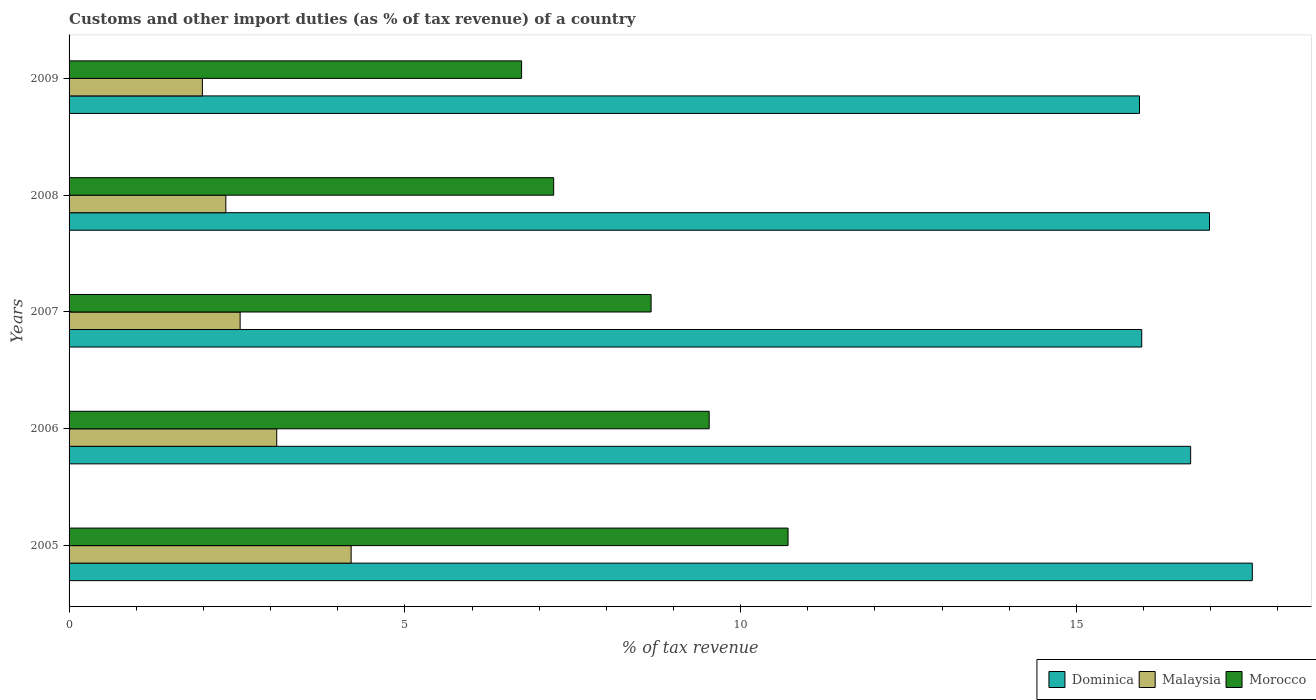How many groups of bars are there?
Offer a very short reply. 5. What is the label of the 3rd group of bars from the top?
Provide a succinct answer. 2007. In how many cases, is the number of bars for a given year not equal to the number of legend labels?
Provide a short and direct response. 0. What is the percentage of tax revenue from customs in Morocco in 2005?
Provide a short and direct response. 10.71. Across all years, what is the maximum percentage of tax revenue from customs in Malaysia?
Provide a short and direct response. 4.2. Across all years, what is the minimum percentage of tax revenue from customs in Morocco?
Ensure brevity in your answer.  6.74. What is the total percentage of tax revenue from customs in Dominica in the graph?
Make the answer very short. 83.21. What is the difference between the percentage of tax revenue from customs in Morocco in 2006 and that in 2009?
Offer a terse response. 2.79. What is the difference between the percentage of tax revenue from customs in Malaysia in 2006 and the percentage of tax revenue from customs in Dominica in 2009?
Offer a terse response. -12.85. What is the average percentage of tax revenue from customs in Dominica per year?
Offer a terse response. 16.64. In the year 2006, what is the difference between the percentage of tax revenue from customs in Dominica and percentage of tax revenue from customs in Malaysia?
Provide a succinct answer. 13.61. What is the ratio of the percentage of tax revenue from customs in Morocco in 2007 to that in 2008?
Provide a short and direct response. 1.2. What is the difference between the highest and the second highest percentage of tax revenue from customs in Morocco?
Your answer should be compact. 1.17. What is the difference between the highest and the lowest percentage of tax revenue from customs in Dominica?
Offer a very short reply. 1.68. In how many years, is the percentage of tax revenue from customs in Dominica greater than the average percentage of tax revenue from customs in Dominica taken over all years?
Give a very brief answer. 3. What does the 1st bar from the top in 2006 represents?
Provide a succinct answer. Morocco. What does the 2nd bar from the bottom in 2005 represents?
Your answer should be very brief. Malaysia. Is it the case that in every year, the sum of the percentage of tax revenue from customs in Dominica and percentage of tax revenue from customs in Malaysia is greater than the percentage of tax revenue from customs in Morocco?
Give a very brief answer. Yes. How many bars are there?
Make the answer very short. 15. Are all the bars in the graph horizontal?
Make the answer very short. Yes. How many years are there in the graph?
Make the answer very short. 5. What is the difference between two consecutive major ticks on the X-axis?
Your answer should be very brief. 5. Does the graph contain grids?
Offer a terse response. No. How many legend labels are there?
Provide a succinct answer. 3. How are the legend labels stacked?
Ensure brevity in your answer.  Horizontal. What is the title of the graph?
Your response must be concise. Customs and other import duties (as % of tax revenue) of a country. What is the label or title of the X-axis?
Offer a very short reply. % of tax revenue. What is the label or title of the Y-axis?
Your answer should be very brief. Years. What is the % of tax revenue in Dominica in 2005?
Your response must be concise. 17.62. What is the % of tax revenue in Malaysia in 2005?
Your answer should be very brief. 4.2. What is the % of tax revenue in Morocco in 2005?
Keep it short and to the point. 10.71. What is the % of tax revenue of Dominica in 2006?
Offer a terse response. 16.7. What is the % of tax revenue in Malaysia in 2006?
Keep it short and to the point. 3.09. What is the % of tax revenue in Morocco in 2006?
Provide a succinct answer. 9.53. What is the % of tax revenue of Dominica in 2007?
Give a very brief answer. 15.97. What is the % of tax revenue of Malaysia in 2007?
Give a very brief answer. 2.55. What is the % of tax revenue in Morocco in 2007?
Your response must be concise. 8.67. What is the % of tax revenue in Dominica in 2008?
Your answer should be very brief. 16.98. What is the % of tax revenue in Malaysia in 2008?
Make the answer very short. 2.33. What is the % of tax revenue in Morocco in 2008?
Offer a very short reply. 7.22. What is the % of tax revenue of Dominica in 2009?
Keep it short and to the point. 15.94. What is the % of tax revenue in Malaysia in 2009?
Keep it short and to the point. 1.99. What is the % of tax revenue in Morocco in 2009?
Provide a short and direct response. 6.74. Across all years, what is the maximum % of tax revenue in Dominica?
Offer a very short reply. 17.62. Across all years, what is the maximum % of tax revenue in Malaysia?
Make the answer very short. 4.2. Across all years, what is the maximum % of tax revenue of Morocco?
Keep it short and to the point. 10.71. Across all years, what is the minimum % of tax revenue of Dominica?
Give a very brief answer. 15.94. Across all years, what is the minimum % of tax revenue of Malaysia?
Give a very brief answer. 1.99. Across all years, what is the minimum % of tax revenue in Morocco?
Give a very brief answer. 6.74. What is the total % of tax revenue of Dominica in the graph?
Ensure brevity in your answer.  83.21. What is the total % of tax revenue in Malaysia in the graph?
Give a very brief answer. 14.16. What is the total % of tax revenue in Morocco in the graph?
Keep it short and to the point. 42.86. What is the difference between the % of tax revenue of Dominica in 2005 and that in 2006?
Your answer should be compact. 0.92. What is the difference between the % of tax revenue in Malaysia in 2005 and that in 2006?
Offer a terse response. 1.11. What is the difference between the % of tax revenue in Morocco in 2005 and that in 2006?
Make the answer very short. 1.17. What is the difference between the % of tax revenue of Dominica in 2005 and that in 2007?
Provide a short and direct response. 1.65. What is the difference between the % of tax revenue of Malaysia in 2005 and that in 2007?
Your answer should be very brief. 1.65. What is the difference between the % of tax revenue in Morocco in 2005 and that in 2007?
Give a very brief answer. 2.04. What is the difference between the % of tax revenue in Dominica in 2005 and that in 2008?
Provide a succinct answer. 0.64. What is the difference between the % of tax revenue in Malaysia in 2005 and that in 2008?
Your answer should be very brief. 1.87. What is the difference between the % of tax revenue of Morocco in 2005 and that in 2008?
Your response must be concise. 3.49. What is the difference between the % of tax revenue of Dominica in 2005 and that in 2009?
Provide a succinct answer. 1.68. What is the difference between the % of tax revenue of Malaysia in 2005 and that in 2009?
Provide a short and direct response. 2.21. What is the difference between the % of tax revenue in Morocco in 2005 and that in 2009?
Keep it short and to the point. 3.97. What is the difference between the % of tax revenue of Dominica in 2006 and that in 2007?
Make the answer very short. 0.73. What is the difference between the % of tax revenue in Malaysia in 2006 and that in 2007?
Your answer should be compact. 0.54. What is the difference between the % of tax revenue of Morocco in 2006 and that in 2007?
Your answer should be very brief. 0.87. What is the difference between the % of tax revenue of Dominica in 2006 and that in 2008?
Provide a short and direct response. -0.28. What is the difference between the % of tax revenue of Malaysia in 2006 and that in 2008?
Your answer should be very brief. 0.76. What is the difference between the % of tax revenue in Morocco in 2006 and that in 2008?
Provide a short and direct response. 2.32. What is the difference between the % of tax revenue of Dominica in 2006 and that in 2009?
Give a very brief answer. 0.76. What is the difference between the % of tax revenue of Malaysia in 2006 and that in 2009?
Give a very brief answer. 1.11. What is the difference between the % of tax revenue in Morocco in 2006 and that in 2009?
Keep it short and to the point. 2.79. What is the difference between the % of tax revenue in Dominica in 2007 and that in 2008?
Your response must be concise. -1.01. What is the difference between the % of tax revenue in Malaysia in 2007 and that in 2008?
Offer a terse response. 0.21. What is the difference between the % of tax revenue in Morocco in 2007 and that in 2008?
Ensure brevity in your answer.  1.45. What is the difference between the % of tax revenue in Dominica in 2007 and that in 2009?
Ensure brevity in your answer.  0.03. What is the difference between the % of tax revenue of Malaysia in 2007 and that in 2009?
Your response must be concise. 0.56. What is the difference between the % of tax revenue of Morocco in 2007 and that in 2009?
Ensure brevity in your answer.  1.93. What is the difference between the % of tax revenue in Dominica in 2008 and that in 2009?
Offer a terse response. 1.04. What is the difference between the % of tax revenue in Malaysia in 2008 and that in 2009?
Offer a very short reply. 0.35. What is the difference between the % of tax revenue in Morocco in 2008 and that in 2009?
Keep it short and to the point. 0.48. What is the difference between the % of tax revenue of Dominica in 2005 and the % of tax revenue of Malaysia in 2006?
Make the answer very short. 14.53. What is the difference between the % of tax revenue in Dominica in 2005 and the % of tax revenue in Morocco in 2006?
Offer a terse response. 8.09. What is the difference between the % of tax revenue of Malaysia in 2005 and the % of tax revenue of Morocco in 2006?
Provide a short and direct response. -5.33. What is the difference between the % of tax revenue of Dominica in 2005 and the % of tax revenue of Malaysia in 2007?
Keep it short and to the point. 15.07. What is the difference between the % of tax revenue of Dominica in 2005 and the % of tax revenue of Morocco in 2007?
Keep it short and to the point. 8.95. What is the difference between the % of tax revenue in Malaysia in 2005 and the % of tax revenue in Morocco in 2007?
Offer a terse response. -4.47. What is the difference between the % of tax revenue in Dominica in 2005 and the % of tax revenue in Malaysia in 2008?
Offer a terse response. 15.28. What is the difference between the % of tax revenue in Dominica in 2005 and the % of tax revenue in Morocco in 2008?
Give a very brief answer. 10.4. What is the difference between the % of tax revenue in Malaysia in 2005 and the % of tax revenue in Morocco in 2008?
Keep it short and to the point. -3.02. What is the difference between the % of tax revenue in Dominica in 2005 and the % of tax revenue in Malaysia in 2009?
Your answer should be compact. 15.63. What is the difference between the % of tax revenue of Dominica in 2005 and the % of tax revenue of Morocco in 2009?
Offer a terse response. 10.88. What is the difference between the % of tax revenue of Malaysia in 2005 and the % of tax revenue of Morocco in 2009?
Provide a succinct answer. -2.54. What is the difference between the % of tax revenue of Dominica in 2006 and the % of tax revenue of Malaysia in 2007?
Keep it short and to the point. 14.15. What is the difference between the % of tax revenue in Dominica in 2006 and the % of tax revenue in Morocco in 2007?
Offer a very short reply. 8.03. What is the difference between the % of tax revenue of Malaysia in 2006 and the % of tax revenue of Morocco in 2007?
Your answer should be very brief. -5.57. What is the difference between the % of tax revenue in Dominica in 2006 and the % of tax revenue in Malaysia in 2008?
Offer a very short reply. 14.37. What is the difference between the % of tax revenue in Dominica in 2006 and the % of tax revenue in Morocco in 2008?
Your answer should be compact. 9.48. What is the difference between the % of tax revenue of Malaysia in 2006 and the % of tax revenue of Morocco in 2008?
Your answer should be compact. -4.12. What is the difference between the % of tax revenue in Dominica in 2006 and the % of tax revenue in Malaysia in 2009?
Provide a short and direct response. 14.72. What is the difference between the % of tax revenue of Dominica in 2006 and the % of tax revenue of Morocco in 2009?
Give a very brief answer. 9.96. What is the difference between the % of tax revenue in Malaysia in 2006 and the % of tax revenue in Morocco in 2009?
Your response must be concise. -3.65. What is the difference between the % of tax revenue in Dominica in 2007 and the % of tax revenue in Malaysia in 2008?
Your answer should be compact. 13.64. What is the difference between the % of tax revenue of Dominica in 2007 and the % of tax revenue of Morocco in 2008?
Your answer should be very brief. 8.76. What is the difference between the % of tax revenue in Malaysia in 2007 and the % of tax revenue in Morocco in 2008?
Provide a short and direct response. -4.67. What is the difference between the % of tax revenue in Dominica in 2007 and the % of tax revenue in Malaysia in 2009?
Offer a very short reply. 13.99. What is the difference between the % of tax revenue in Dominica in 2007 and the % of tax revenue in Morocco in 2009?
Offer a very short reply. 9.23. What is the difference between the % of tax revenue of Malaysia in 2007 and the % of tax revenue of Morocco in 2009?
Provide a succinct answer. -4.19. What is the difference between the % of tax revenue of Dominica in 2008 and the % of tax revenue of Malaysia in 2009?
Your response must be concise. 15. What is the difference between the % of tax revenue in Dominica in 2008 and the % of tax revenue in Morocco in 2009?
Make the answer very short. 10.24. What is the difference between the % of tax revenue in Malaysia in 2008 and the % of tax revenue in Morocco in 2009?
Ensure brevity in your answer.  -4.4. What is the average % of tax revenue of Dominica per year?
Provide a succinct answer. 16.64. What is the average % of tax revenue in Malaysia per year?
Your response must be concise. 2.83. What is the average % of tax revenue of Morocco per year?
Offer a terse response. 8.57. In the year 2005, what is the difference between the % of tax revenue in Dominica and % of tax revenue in Malaysia?
Your answer should be very brief. 13.42. In the year 2005, what is the difference between the % of tax revenue of Dominica and % of tax revenue of Morocco?
Keep it short and to the point. 6.91. In the year 2005, what is the difference between the % of tax revenue in Malaysia and % of tax revenue in Morocco?
Your answer should be very brief. -6.51. In the year 2006, what is the difference between the % of tax revenue of Dominica and % of tax revenue of Malaysia?
Offer a terse response. 13.61. In the year 2006, what is the difference between the % of tax revenue of Dominica and % of tax revenue of Morocco?
Provide a short and direct response. 7.17. In the year 2006, what is the difference between the % of tax revenue of Malaysia and % of tax revenue of Morocco?
Keep it short and to the point. -6.44. In the year 2007, what is the difference between the % of tax revenue of Dominica and % of tax revenue of Malaysia?
Offer a terse response. 13.42. In the year 2007, what is the difference between the % of tax revenue in Dominica and % of tax revenue in Morocco?
Offer a very short reply. 7.31. In the year 2007, what is the difference between the % of tax revenue of Malaysia and % of tax revenue of Morocco?
Provide a succinct answer. -6.12. In the year 2008, what is the difference between the % of tax revenue of Dominica and % of tax revenue of Malaysia?
Provide a short and direct response. 14.65. In the year 2008, what is the difference between the % of tax revenue of Dominica and % of tax revenue of Morocco?
Your answer should be compact. 9.77. In the year 2008, what is the difference between the % of tax revenue in Malaysia and % of tax revenue in Morocco?
Offer a terse response. -4.88. In the year 2009, what is the difference between the % of tax revenue in Dominica and % of tax revenue in Malaysia?
Your answer should be compact. 13.95. In the year 2009, what is the difference between the % of tax revenue of Dominica and % of tax revenue of Morocco?
Give a very brief answer. 9.2. In the year 2009, what is the difference between the % of tax revenue of Malaysia and % of tax revenue of Morocco?
Ensure brevity in your answer.  -4.75. What is the ratio of the % of tax revenue in Dominica in 2005 to that in 2006?
Your answer should be compact. 1.05. What is the ratio of the % of tax revenue in Malaysia in 2005 to that in 2006?
Provide a short and direct response. 1.36. What is the ratio of the % of tax revenue of Morocco in 2005 to that in 2006?
Make the answer very short. 1.12. What is the ratio of the % of tax revenue of Dominica in 2005 to that in 2007?
Your response must be concise. 1.1. What is the ratio of the % of tax revenue in Malaysia in 2005 to that in 2007?
Give a very brief answer. 1.65. What is the ratio of the % of tax revenue in Morocco in 2005 to that in 2007?
Your answer should be very brief. 1.24. What is the ratio of the % of tax revenue in Dominica in 2005 to that in 2008?
Offer a very short reply. 1.04. What is the ratio of the % of tax revenue in Malaysia in 2005 to that in 2008?
Offer a very short reply. 1.8. What is the ratio of the % of tax revenue in Morocco in 2005 to that in 2008?
Make the answer very short. 1.48. What is the ratio of the % of tax revenue in Dominica in 2005 to that in 2009?
Your response must be concise. 1.11. What is the ratio of the % of tax revenue in Malaysia in 2005 to that in 2009?
Provide a short and direct response. 2.12. What is the ratio of the % of tax revenue of Morocco in 2005 to that in 2009?
Provide a succinct answer. 1.59. What is the ratio of the % of tax revenue of Dominica in 2006 to that in 2007?
Offer a very short reply. 1.05. What is the ratio of the % of tax revenue of Malaysia in 2006 to that in 2007?
Offer a terse response. 1.21. What is the ratio of the % of tax revenue of Morocco in 2006 to that in 2007?
Make the answer very short. 1.1. What is the ratio of the % of tax revenue of Dominica in 2006 to that in 2008?
Your answer should be compact. 0.98. What is the ratio of the % of tax revenue of Malaysia in 2006 to that in 2008?
Your answer should be very brief. 1.32. What is the ratio of the % of tax revenue of Morocco in 2006 to that in 2008?
Keep it short and to the point. 1.32. What is the ratio of the % of tax revenue of Dominica in 2006 to that in 2009?
Offer a very short reply. 1.05. What is the ratio of the % of tax revenue of Malaysia in 2006 to that in 2009?
Make the answer very short. 1.56. What is the ratio of the % of tax revenue of Morocco in 2006 to that in 2009?
Make the answer very short. 1.41. What is the ratio of the % of tax revenue in Dominica in 2007 to that in 2008?
Give a very brief answer. 0.94. What is the ratio of the % of tax revenue in Malaysia in 2007 to that in 2008?
Ensure brevity in your answer.  1.09. What is the ratio of the % of tax revenue in Morocco in 2007 to that in 2008?
Offer a very short reply. 1.2. What is the ratio of the % of tax revenue in Malaysia in 2007 to that in 2009?
Keep it short and to the point. 1.28. What is the ratio of the % of tax revenue of Morocco in 2007 to that in 2009?
Give a very brief answer. 1.29. What is the ratio of the % of tax revenue of Dominica in 2008 to that in 2009?
Ensure brevity in your answer.  1.07. What is the ratio of the % of tax revenue in Malaysia in 2008 to that in 2009?
Offer a terse response. 1.18. What is the ratio of the % of tax revenue in Morocco in 2008 to that in 2009?
Make the answer very short. 1.07. What is the difference between the highest and the second highest % of tax revenue in Dominica?
Give a very brief answer. 0.64. What is the difference between the highest and the second highest % of tax revenue in Malaysia?
Ensure brevity in your answer.  1.11. What is the difference between the highest and the second highest % of tax revenue in Morocco?
Provide a short and direct response. 1.17. What is the difference between the highest and the lowest % of tax revenue of Dominica?
Provide a short and direct response. 1.68. What is the difference between the highest and the lowest % of tax revenue of Malaysia?
Your response must be concise. 2.21. What is the difference between the highest and the lowest % of tax revenue in Morocco?
Ensure brevity in your answer.  3.97. 